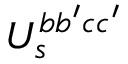Convert formula to latex. <formula><loc_0><loc_0><loc_500><loc_500>U _ { s } ^ { b b ^ { \prime } c c ^ { \prime } }</formula> 